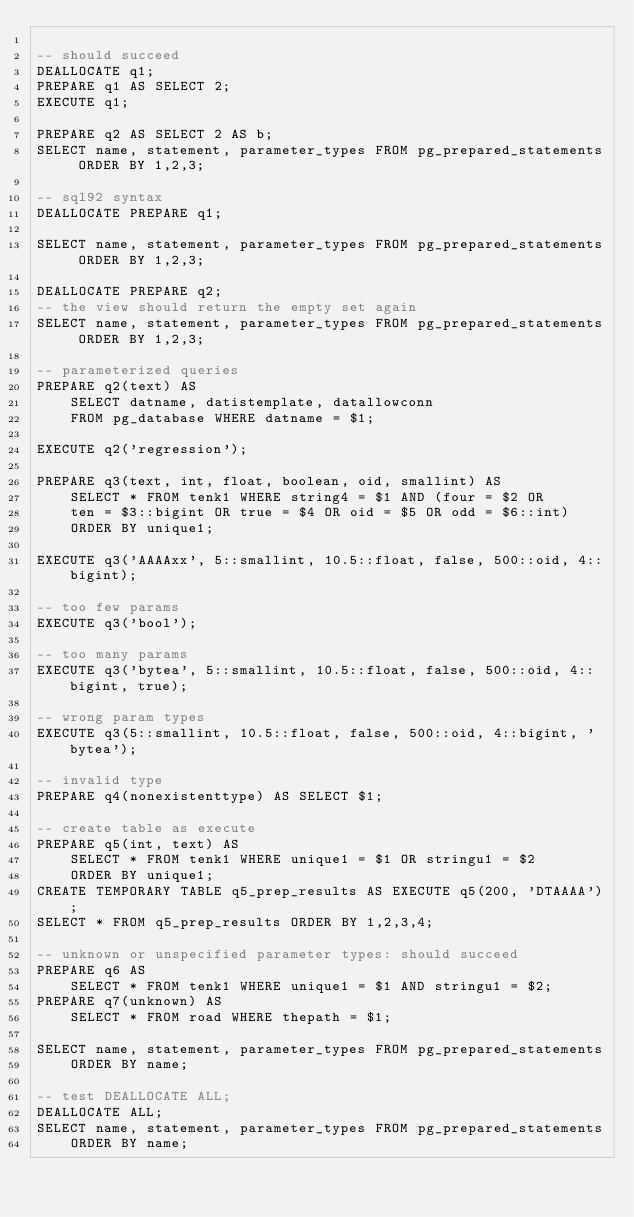Convert code to text. <code><loc_0><loc_0><loc_500><loc_500><_SQL_>
-- should succeed
DEALLOCATE q1;
PREPARE q1 AS SELECT 2;
EXECUTE q1;

PREPARE q2 AS SELECT 2 AS b;
SELECT name, statement, parameter_types FROM pg_prepared_statements ORDER BY 1,2,3;

-- sql92 syntax
DEALLOCATE PREPARE q1;

SELECT name, statement, parameter_types FROM pg_prepared_statements ORDER BY 1,2,3;

DEALLOCATE PREPARE q2;
-- the view should return the empty set again
SELECT name, statement, parameter_types FROM pg_prepared_statements ORDER BY 1,2,3;

-- parameterized queries
PREPARE q2(text) AS
	SELECT datname, datistemplate, datallowconn
	FROM pg_database WHERE datname = $1;

EXECUTE q2('regression');

PREPARE q3(text, int, float, boolean, oid, smallint) AS
	SELECT * FROM tenk1 WHERE string4 = $1 AND (four = $2 OR
	ten = $3::bigint OR true = $4 OR oid = $5 OR odd = $6::int)
	ORDER BY unique1;

EXECUTE q3('AAAAxx', 5::smallint, 10.5::float, false, 500::oid, 4::bigint);

-- too few params
EXECUTE q3('bool');

-- too many params
EXECUTE q3('bytea', 5::smallint, 10.5::float, false, 500::oid, 4::bigint, true);

-- wrong param types
EXECUTE q3(5::smallint, 10.5::float, false, 500::oid, 4::bigint, 'bytea');

-- invalid type
PREPARE q4(nonexistenttype) AS SELECT $1;

-- create table as execute
PREPARE q5(int, text) AS
	SELECT * FROM tenk1 WHERE unique1 = $1 OR stringu1 = $2
	ORDER BY unique1;
CREATE TEMPORARY TABLE q5_prep_results AS EXECUTE q5(200, 'DTAAAA');
SELECT * FROM q5_prep_results ORDER BY 1,2,3,4;

-- unknown or unspecified parameter types: should succeed
PREPARE q6 AS
    SELECT * FROM tenk1 WHERE unique1 = $1 AND stringu1 = $2;
PREPARE q7(unknown) AS
    SELECT * FROM road WHERE thepath = $1;

SELECT name, statement, parameter_types FROM pg_prepared_statements
    ORDER BY name;

-- test DEALLOCATE ALL;
DEALLOCATE ALL;
SELECT name, statement, parameter_types FROM pg_prepared_statements
    ORDER BY name;

</code> 